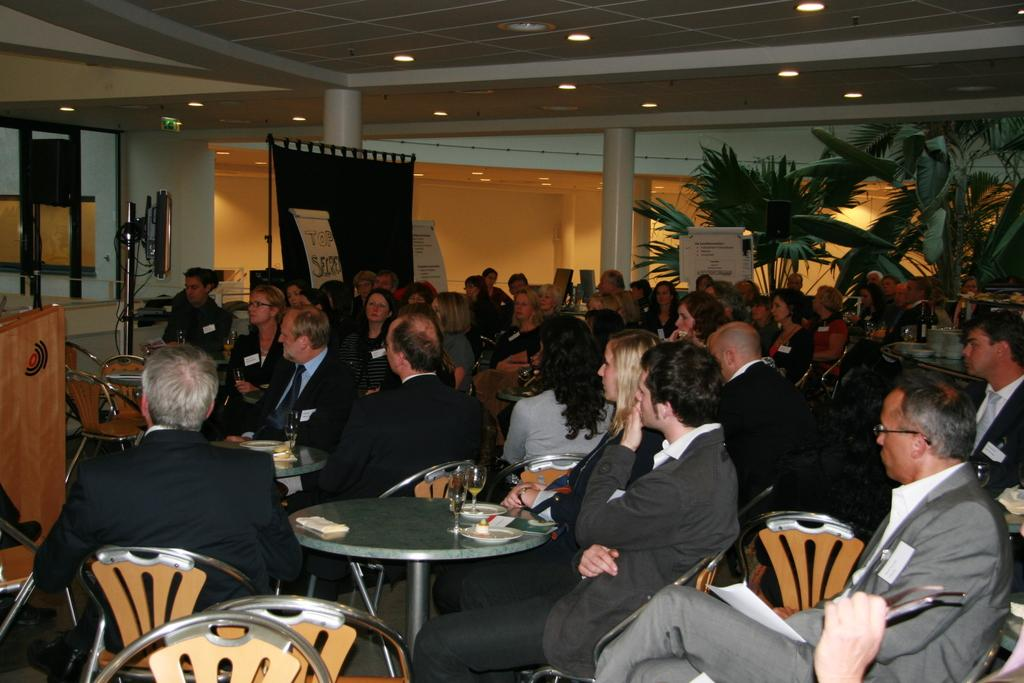How many people are in the image? There is a group of people in the image. What are the people doing in the image? The people are seated on chairs. What can be seen on the table in the image? There are wine glasses on the table. What type of vegetation is present in the image? There are plants in the image. What electronic device is visible in the image? There is a television in the image. What type of furniture is present in the image? There is a podium in the image. What type of skin is visible on the zebra in the image? There is no zebra present in the image, so there is no skin to describe. 